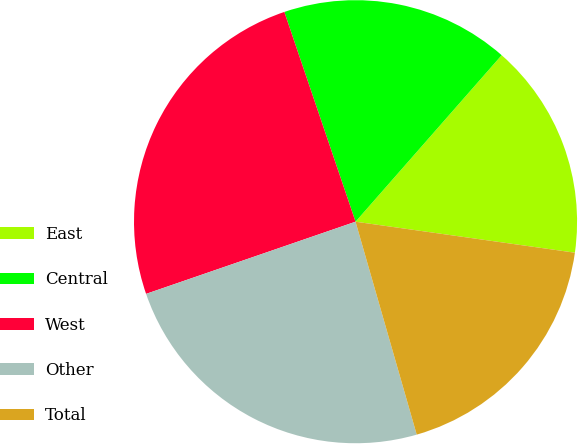<chart> <loc_0><loc_0><loc_500><loc_500><pie_chart><fcel>East<fcel>Central<fcel>West<fcel>Other<fcel>Total<nl><fcel>15.77%<fcel>16.67%<fcel>25.07%<fcel>24.17%<fcel>18.31%<nl></chart> 